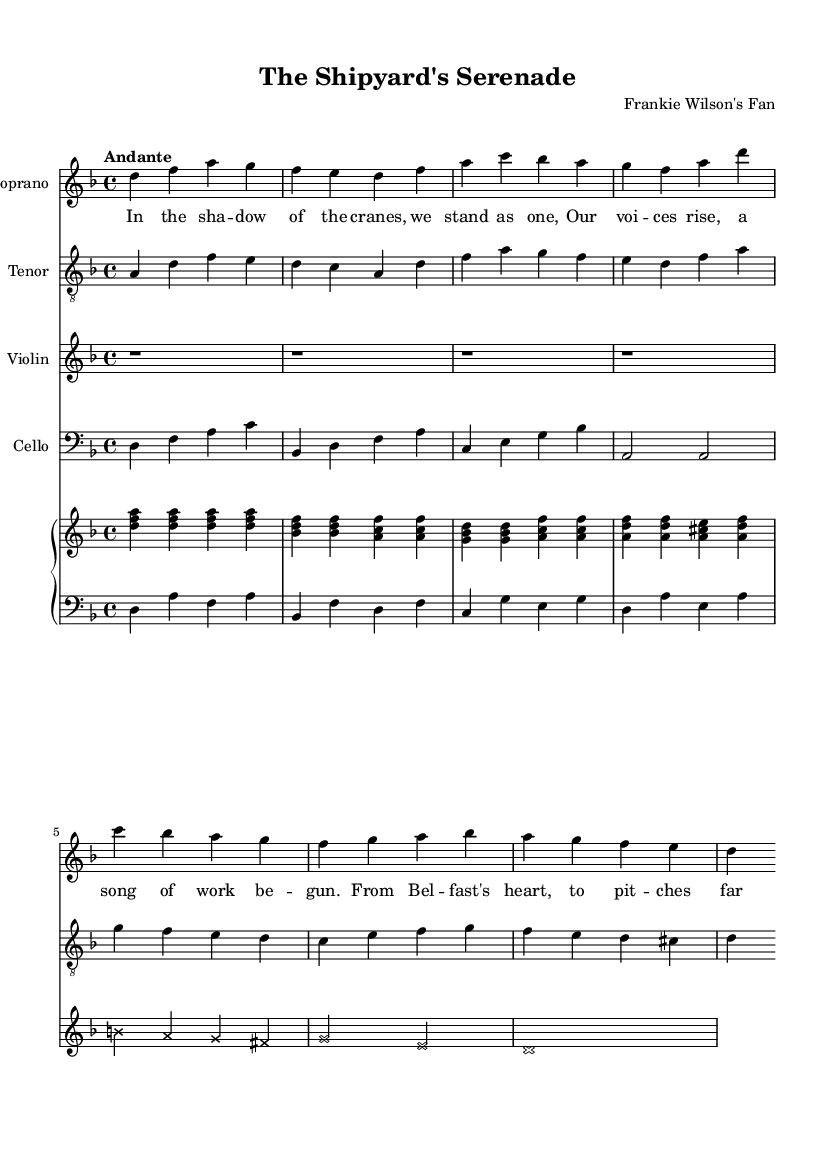What is the key signature of this music? The key signature is indicated at the beginning of the score. Here, it shows one flat, which defines D minor as the key.
Answer: D minor What is the time signature of the piece? The time signature is located at the beginning of the score, shown as 4/4, indicating that there are four beats in each measure and the quarter note gets one beat.
Answer: 4/4 What is the tempo marking for this piece? The tempo is noted at the beginning of the score with the term "Andante," which suggests a moderate tempo.
Answer: Andante How many voices are represented in the score? The score has four distinct voices shown: Soprano, Tenor, Violin, and Cello, indicating the total number of vocal and instrumental parts.
Answer: Four Which instruments have their music written on the treble and bass clefs? The Soprano and Tenor parts are written in treble clef, and the Cello part is written in bass clef. The piano also has both treble and bass staves for the left and right hands.
Answer: Soprano, Tenor (treble); Cello (bass) What theme does the lyric of this opera convey? The lyrics reflect themes of community and pride among working-class people, indicative of shared experiences typical in many opera narratives.
Answer: Community pride How does the musical line for the Violin relate to the overall theme? The Violin line interacts with the voices, adding emotional depth and reflecting the lyrical content's focus on unity and work, enhancing the drama and support for the singers.
Answer: Emotional depth 